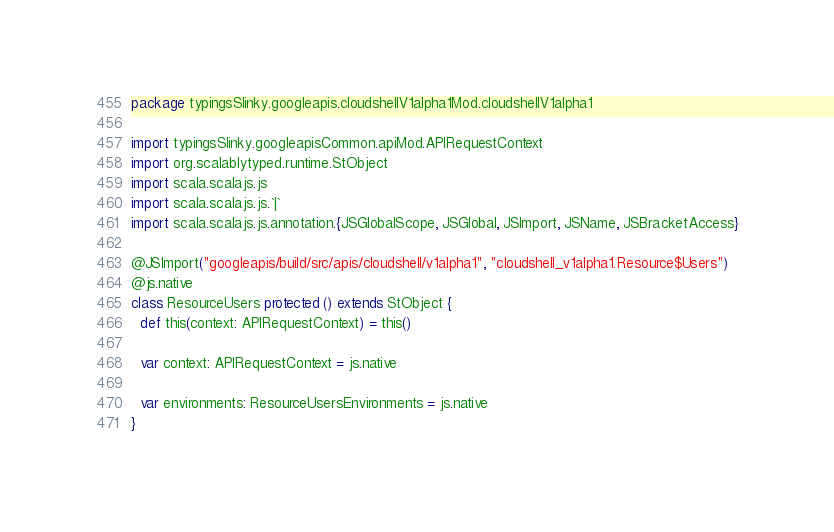Convert code to text. <code><loc_0><loc_0><loc_500><loc_500><_Scala_>package typingsSlinky.googleapis.cloudshellV1alpha1Mod.cloudshellV1alpha1

import typingsSlinky.googleapisCommon.apiMod.APIRequestContext
import org.scalablytyped.runtime.StObject
import scala.scalajs.js
import scala.scalajs.js.`|`
import scala.scalajs.js.annotation.{JSGlobalScope, JSGlobal, JSImport, JSName, JSBracketAccess}

@JSImport("googleapis/build/src/apis/cloudshell/v1alpha1", "cloudshell_v1alpha1.Resource$Users")
@js.native
class ResourceUsers protected () extends StObject {
  def this(context: APIRequestContext) = this()
  
  var context: APIRequestContext = js.native
  
  var environments: ResourceUsersEnvironments = js.native
}
</code> 